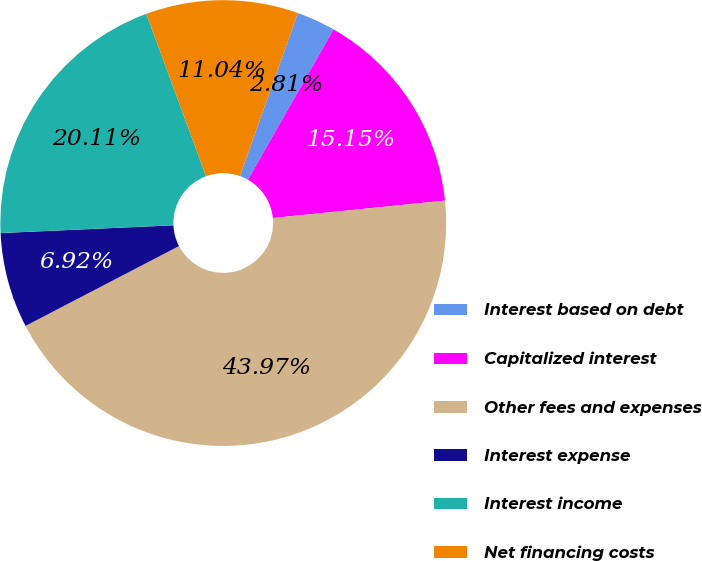Convert chart. <chart><loc_0><loc_0><loc_500><loc_500><pie_chart><fcel>Interest based on debt<fcel>Capitalized interest<fcel>Other fees and expenses<fcel>Interest expense<fcel>Interest income<fcel>Net financing costs<nl><fcel>2.81%<fcel>15.15%<fcel>43.97%<fcel>6.92%<fcel>20.11%<fcel>11.04%<nl></chart> 